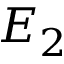Convert formula to latex. <formula><loc_0><loc_0><loc_500><loc_500>E _ { 2 }</formula> 